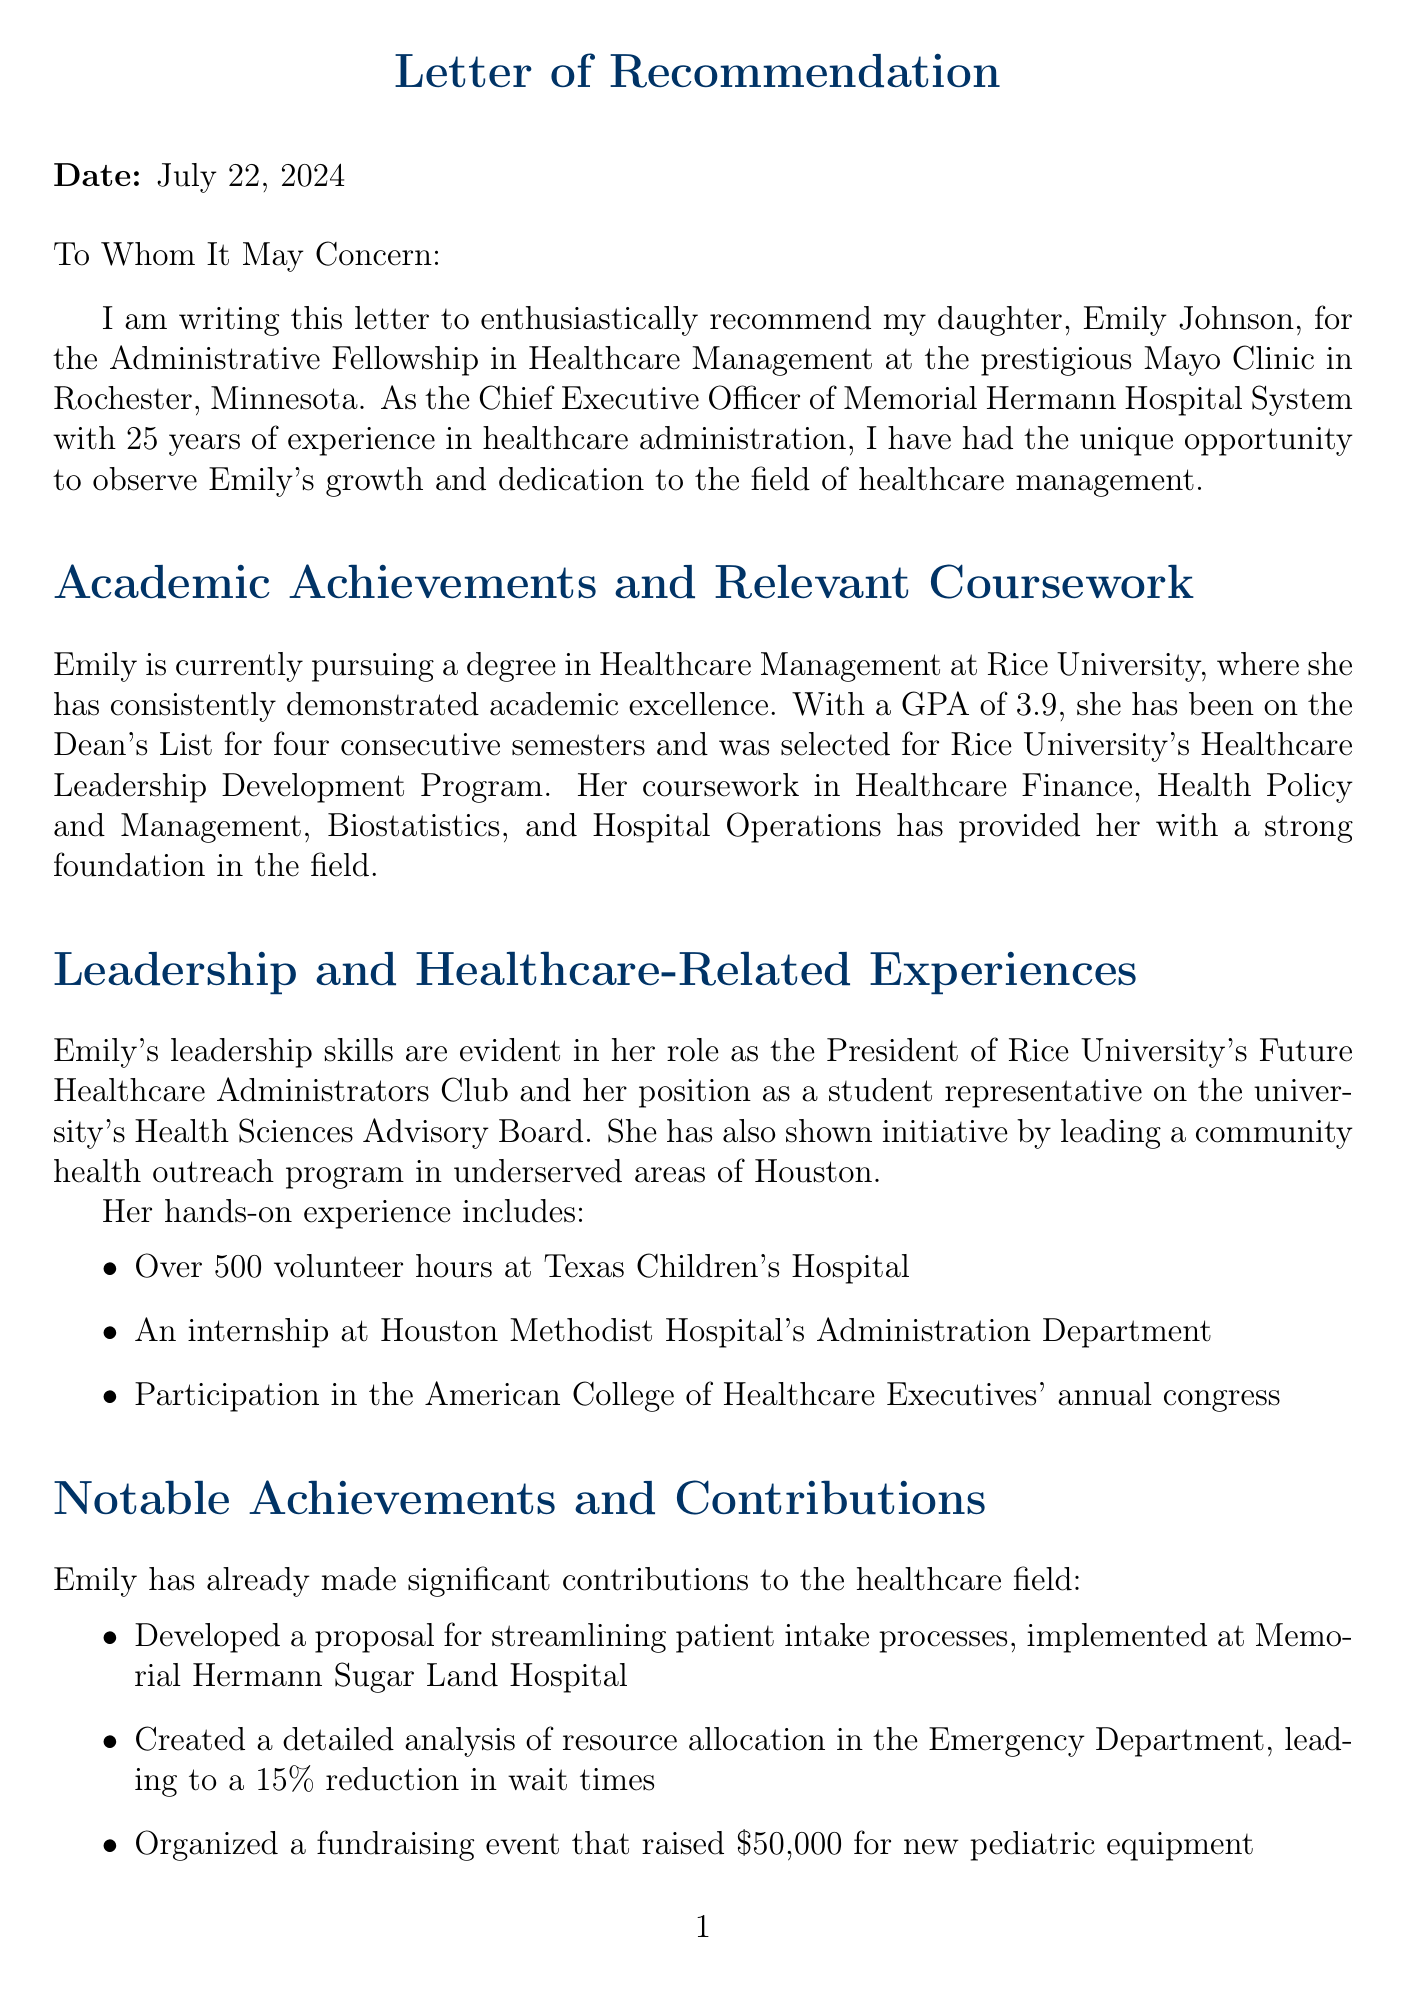What is the name of the child being recommended? The letter explicitly states the name of the child being recommended for the internship.
Answer: Emily Johnson What is the child’s GPA? The letter mentions Emily's GPA as part of her academic achievements.
Answer: 3.9 Which prestigious healthcare facility is the internship application for? The facility is named in the introduction of the letter.
Answer: Mayo Clinic How many volunteer hours did Emily accumulate at Texas Children's Hospital? The letter specifies the total number of volunteer hours described.
Answer: 500 What role does Dr. Sarah Johnson hold? The letter identifies Dr. Sarah Johnson's position in the healthcare field.
Answer: Chief Executive Officer What significant initiative did Dr. Sarah Johnson lead at Memorial Hermann? The letter provides specific achievements regarding her leadership.
Answer: Implemented system-wide electronic health records How many semesters has Emily been on the Dean’s List? The letter specifically states the duration of Emily’s academic recognition.
Answer: Four consecutive semesters What amount was raised in the fundraising event organized by Emily? The letter includes the exact amount raised during the event.
Answer: $50,000 What is Emily’s major? The letter indicates her area of study at university.
Answer: Healthcare Management 